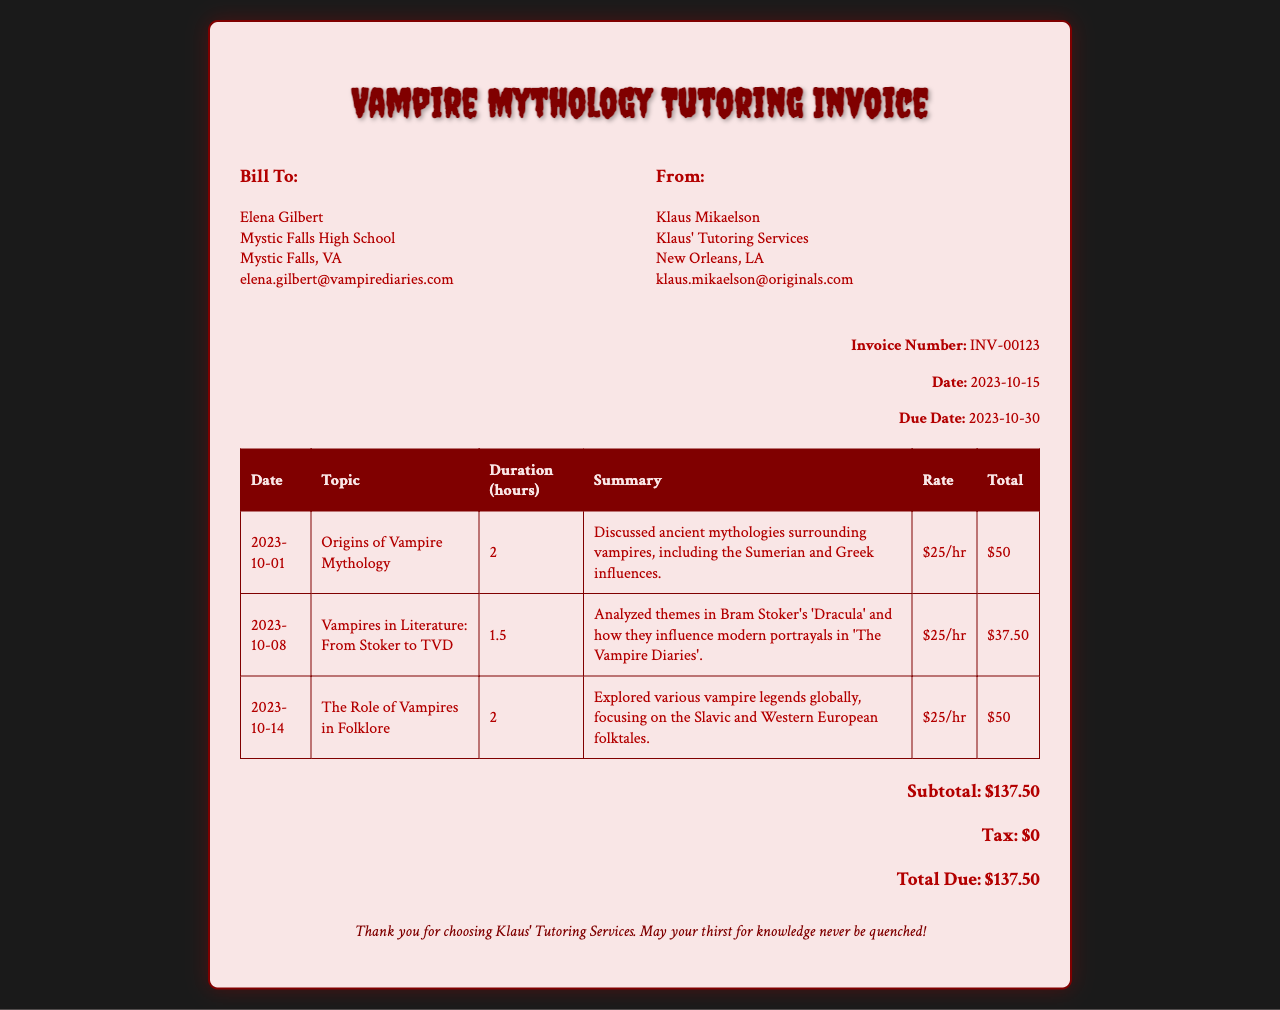What is the invoice number? The invoice number is identified in the invoice details section.
Answer: INV-00123 Who is the client? The client is listed at the top under the "Bill To" section.
Answer: Elena Gilbert What is the date of the invoice? The date of the invoice is specified in the invoice details section.
Answer: 2023-10-15 How many hours of tutoring were provided on 2023-10-08? The duration of the tutoring session on this date is noted in the table.
Answer: 1.5 What is the subtotal amount due? The subtotal is calculated from the total hours and rates in the invoice.
Answer: $137.50 What topic was covered in the session on 2023-10-14? The topic is mentioned in the corresponding row of the table.
Answer: The Role of Vampires in Folklore Who provided the tutoring services? The provider is indicated in the "From" section of the invoice.
Answer: Klaus Mikaelson What is the total due amount? The total due amount is presented at the bottom of the invoice.
Answer: $137.50 What themes were analyzed in the session about Bram Stoker's 'Dracula'? This information can be found in the summary of the related tutoring session.
Answer: Themes in Bram Stoker's 'Dracula' and their influence 